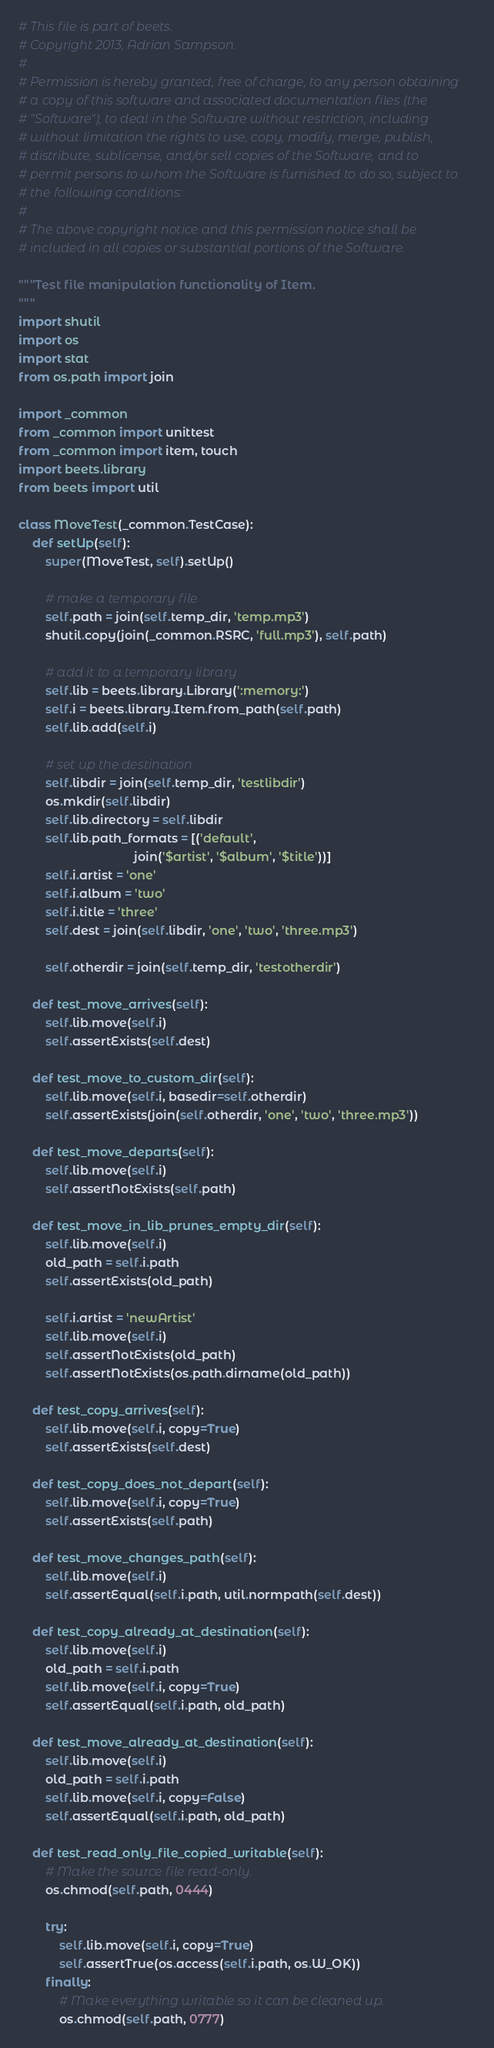<code> <loc_0><loc_0><loc_500><loc_500><_Python_># This file is part of beets.
# Copyright 2013, Adrian Sampson.
#
# Permission is hereby granted, free of charge, to any person obtaining
# a copy of this software and associated documentation files (the
# "Software"), to deal in the Software without restriction, including
# without limitation the rights to use, copy, modify, merge, publish,
# distribute, sublicense, and/or sell copies of the Software, and to
# permit persons to whom the Software is furnished to do so, subject to
# the following conditions:
#
# The above copyright notice and this permission notice shall be
# included in all copies or substantial portions of the Software.

"""Test file manipulation functionality of Item.
"""
import shutil
import os
import stat
from os.path import join

import _common
from _common import unittest
from _common import item, touch
import beets.library
from beets import util

class MoveTest(_common.TestCase):
    def setUp(self):
        super(MoveTest, self).setUp()

        # make a temporary file
        self.path = join(self.temp_dir, 'temp.mp3')
        shutil.copy(join(_common.RSRC, 'full.mp3'), self.path)

        # add it to a temporary library
        self.lib = beets.library.Library(':memory:')
        self.i = beets.library.Item.from_path(self.path)
        self.lib.add(self.i)

        # set up the destination
        self.libdir = join(self.temp_dir, 'testlibdir')
        os.mkdir(self.libdir)
        self.lib.directory = self.libdir
        self.lib.path_formats = [('default',
                                  join('$artist', '$album', '$title'))]
        self.i.artist = 'one'
        self.i.album = 'two'
        self.i.title = 'three'
        self.dest = join(self.libdir, 'one', 'two', 'three.mp3')

        self.otherdir = join(self.temp_dir, 'testotherdir')

    def test_move_arrives(self):
        self.lib.move(self.i)
        self.assertExists(self.dest)

    def test_move_to_custom_dir(self):
        self.lib.move(self.i, basedir=self.otherdir)
        self.assertExists(join(self.otherdir, 'one', 'two', 'three.mp3'))

    def test_move_departs(self):
        self.lib.move(self.i)
        self.assertNotExists(self.path)

    def test_move_in_lib_prunes_empty_dir(self):
        self.lib.move(self.i)
        old_path = self.i.path
        self.assertExists(old_path)

        self.i.artist = 'newArtist'
        self.lib.move(self.i)
        self.assertNotExists(old_path)
        self.assertNotExists(os.path.dirname(old_path))

    def test_copy_arrives(self):
        self.lib.move(self.i, copy=True)
        self.assertExists(self.dest)

    def test_copy_does_not_depart(self):
        self.lib.move(self.i, copy=True)
        self.assertExists(self.path)

    def test_move_changes_path(self):
        self.lib.move(self.i)
        self.assertEqual(self.i.path, util.normpath(self.dest))

    def test_copy_already_at_destination(self):
        self.lib.move(self.i)
        old_path = self.i.path
        self.lib.move(self.i, copy=True)
        self.assertEqual(self.i.path, old_path)

    def test_move_already_at_destination(self):
        self.lib.move(self.i)
        old_path = self.i.path
        self.lib.move(self.i, copy=False)
        self.assertEqual(self.i.path, old_path)

    def test_read_only_file_copied_writable(self):
        # Make the source file read-only.
        os.chmod(self.path, 0444)

        try:
            self.lib.move(self.i, copy=True)
            self.assertTrue(os.access(self.i.path, os.W_OK))
        finally:
            # Make everything writable so it can be cleaned up.
            os.chmod(self.path, 0777)</code> 